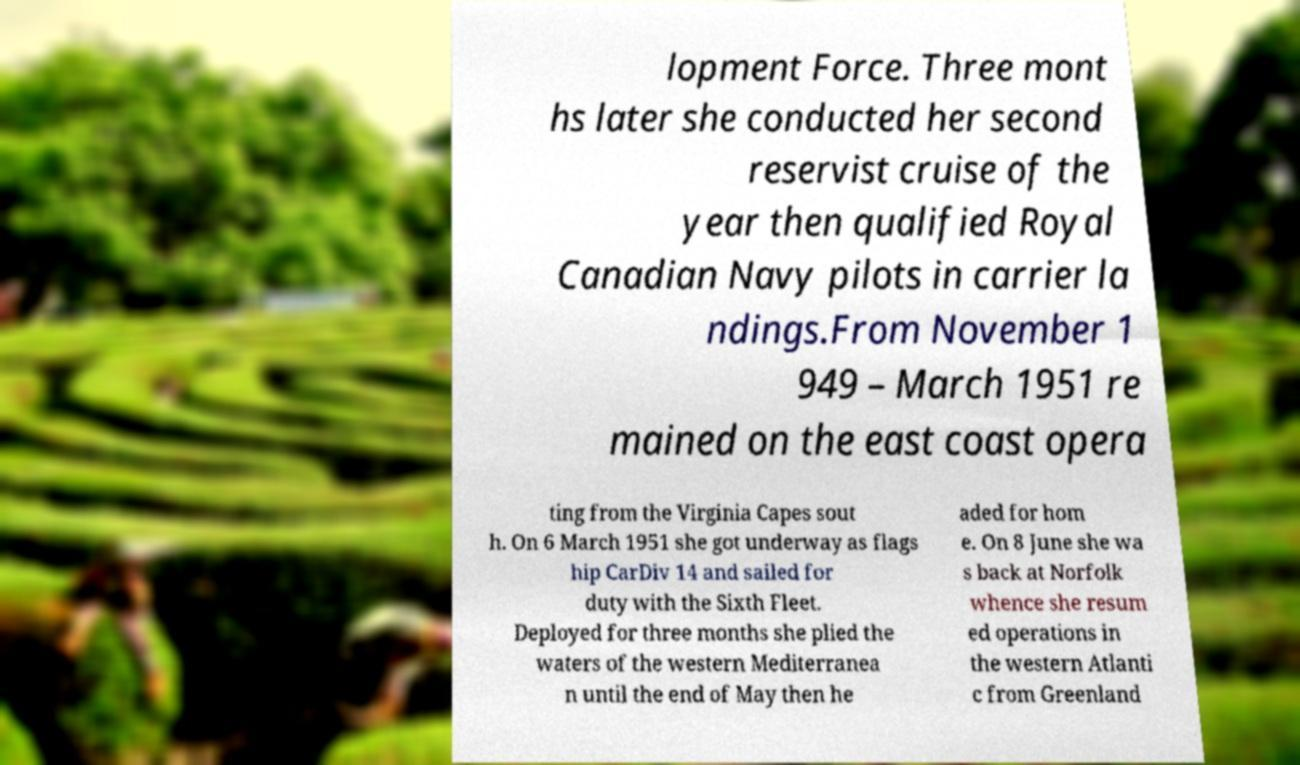Could you extract and type out the text from this image? lopment Force. Three mont hs later she conducted her second reservist cruise of the year then qualified Royal Canadian Navy pilots in carrier la ndings.From November 1 949 – March 1951 re mained on the east coast opera ting from the Virginia Capes sout h. On 6 March 1951 she got underway as flags hip CarDiv 14 and sailed for duty with the Sixth Fleet. Deployed for three months she plied the waters of the western Mediterranea n until the end of May then he aded for hom e. On 8 June she wa s back at Norfolk whence she resum ed operations in the western Atlanti c from Greenland 